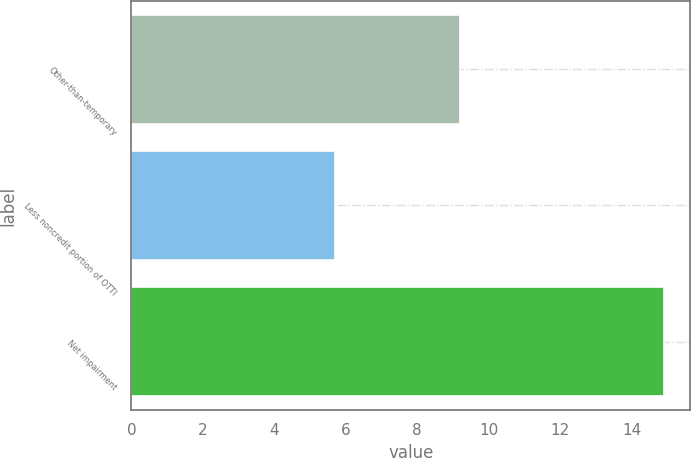Convert chart. <chart><loc_0><loc_0><loc_500><loc_500><bar_chart><fcel>Other-than-temporary<fcel>Less noncredit portion of OTTI<fcel>Net impairment<nl><fcel>9.2<fcel>5.7<fcel>14.9<nl></chart> 